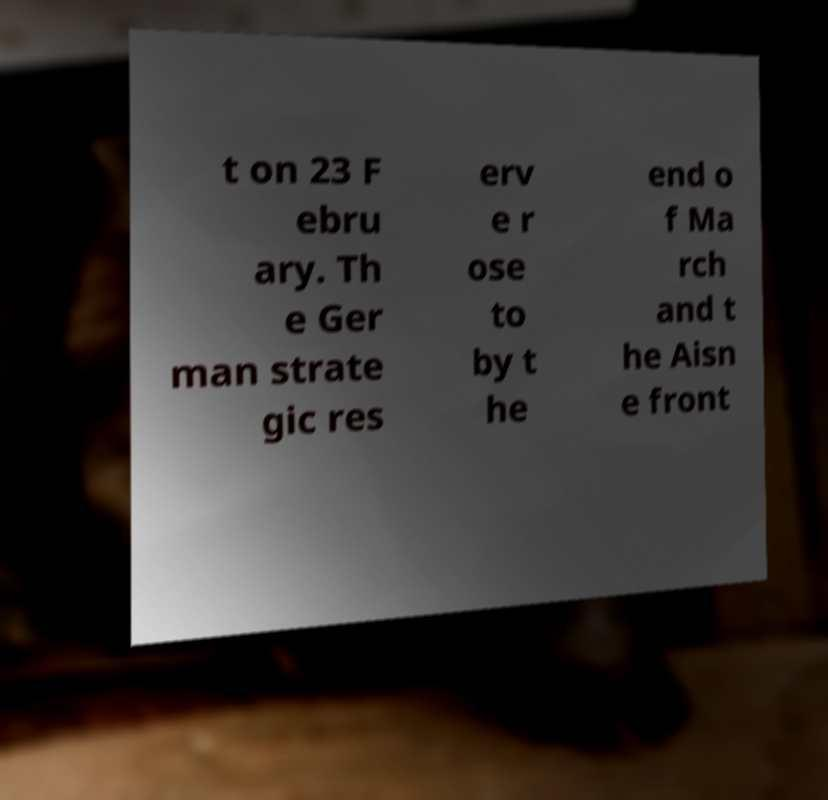There's text embedded in this image that I need extracted. Can you transcribe it verbatim? t on 23 F ebru ary. Th e Ger man strate gic res erv e r ose to by t he end o f Ma rch and t he Aisn e front 